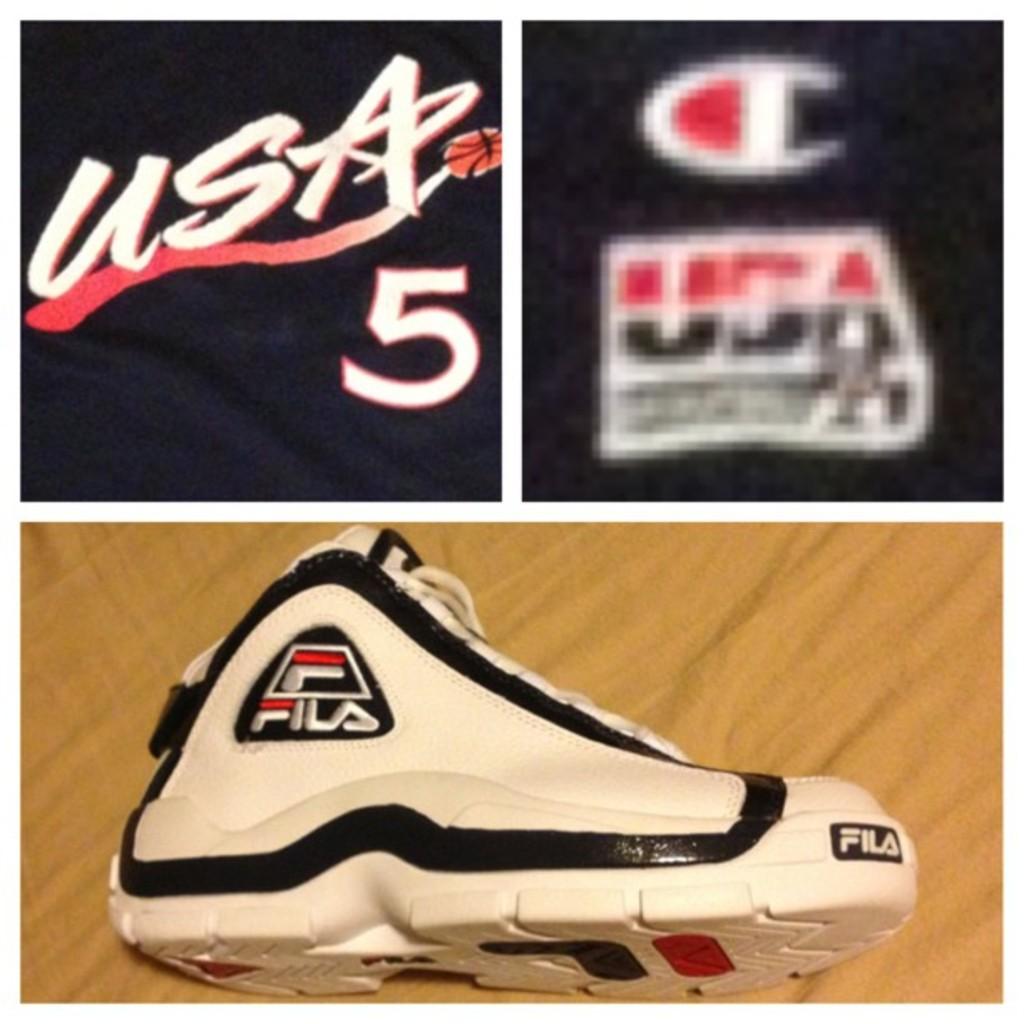What number is under usa?
Your answer should be compact. 5. 